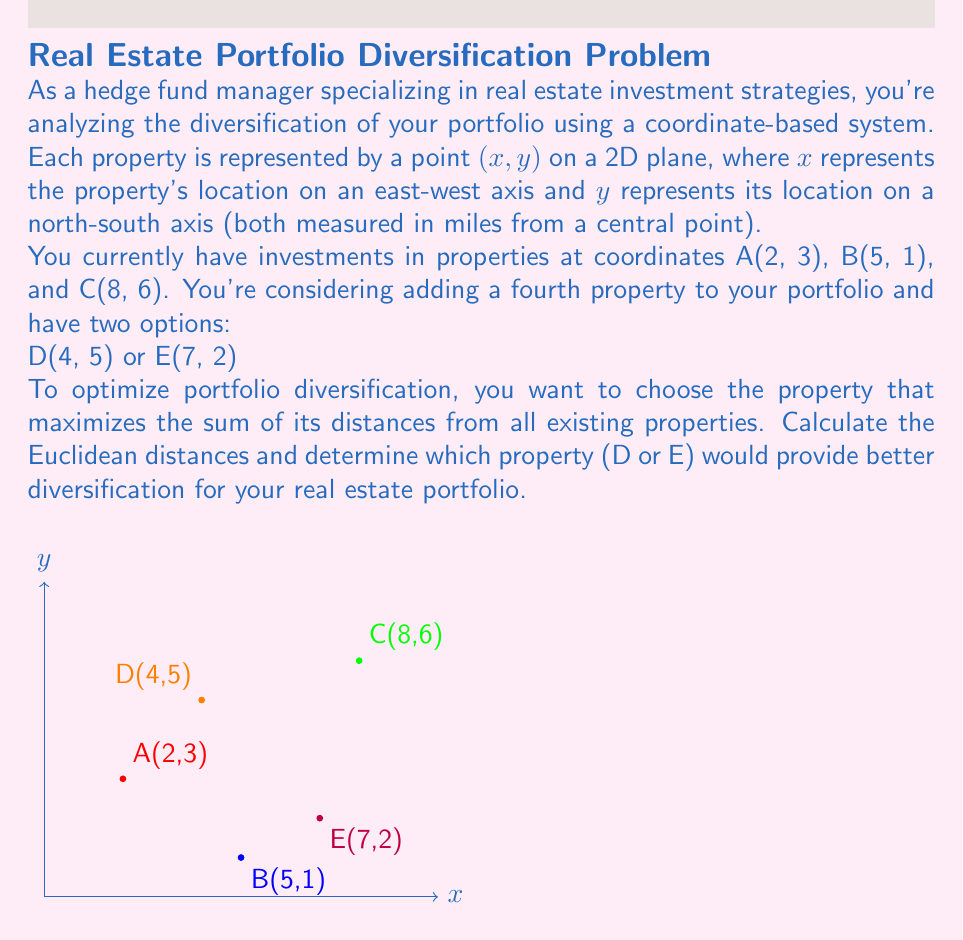What is the answer to this math problem? Let's approach this step-by-step:

1) First, recall the Euclidean distance formula between two points (x₁, y₁) and (x₂, y₂):

   $$d = \sqrt{(x_2 - x_1)^2 + (y_2 - y_1)^2}$$

2) Now, let's calculate the distances from D(4, 5) to each existing property:

   AD = $\sqrt{(4-2)^2 + (5-3)^2} = \sqrt{4 + 4} = \sqrt{8} = 2\sqrt{2}$
   BD = $\sqrt{(4-5)^2 + (5-1)^2} = \sqrt{1 + 16} = \sqrt{17}$
   CD = $\sqrt{(4-8)^2 + (5-6)^2} = \sqrt{16 + 1} = \sqrt{17}$

3) The sum of distances for D is:

   $2\sqrt{2} + \sqrt{17} + \sqrt{17} = 2\sqrt{2} + 2\sqrt{17}$

4) Now, let's calculate the distances from E(7, 2) to each existing property:

   AE = $\sqrt{(7-2)^2 + (2-3)^2} = \sqrt{25 + 1} = \sqrt{26}$
   BE = $\sqrt{(7-5)^2 + (2-1)^2} = \sqrt{4 + 1} = \sqrt{5}$
   CE = $\sqrt{(7-8)^2 + (2-6)^2} = \sqrt{1 + 16} = \sqrt{17}$

5) The sum of distances for E is:

   $\sqrt{26} + \sqrt{5} + \sqrt{17}$

6) To compare, we need to determine which is larger:

   $2\sqrt{2} + 2\sqrt{17}$ or $\sqrt{26} + \sqrt{5} + \sqrt{17}$

   This is not immediately obvious, so let's square both sides to remove the square roots:

   $(2\sqrt{2} + 2\sqrt{17})^2 = 8 + 68 + 8\sqrt{34} = 76 + 8\sqrt{34}$
   $(\sqrt{26} + \sqrt{5} + \sqrt{17})^2 = 26 + 5 + 17 + 2\sqrt{130} + 2\sqrt{442} + 2\sqrt{85} = 48 + 2\sqrt{130} + 2\sqrt{442} + 2\sqrt{85}$

   The right side is clearly larger, so E provides better diversification.
Answer: E(7, 2) 